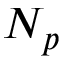Convert formula to latex. <formula><loc_0><loc_0><loc_500><loc_500>N _ { p }</formula> 